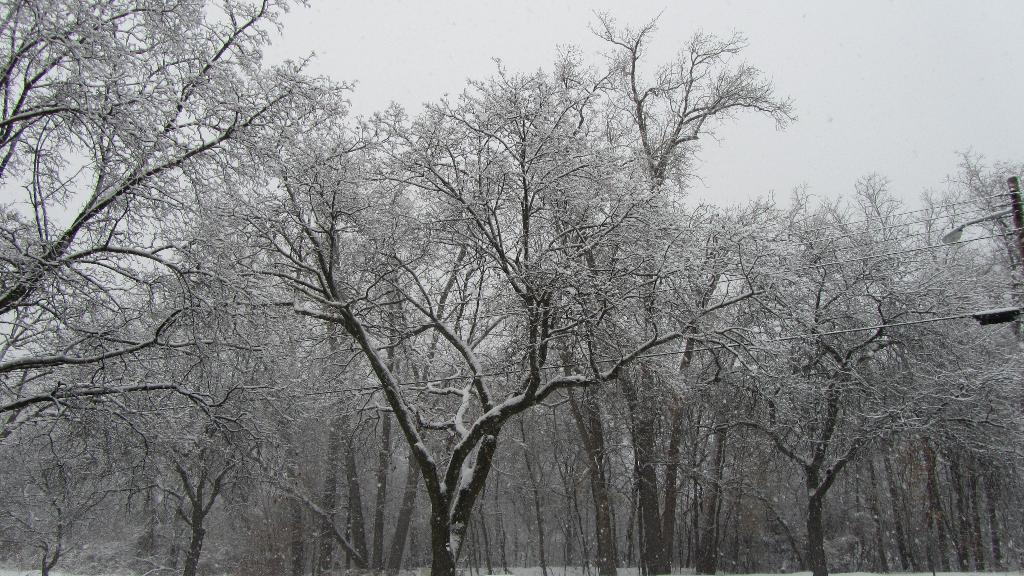What is located in the middle of the image? There are trees in the middle of the image. What is visible at the top of the image? There is sky visible at the top of the image. What type of substance is present in the image? There is ice in the image. What type of pickle is being dropped from the sky in the image? There is no pickle present in the image, nor is anything being dropped from the sky. 